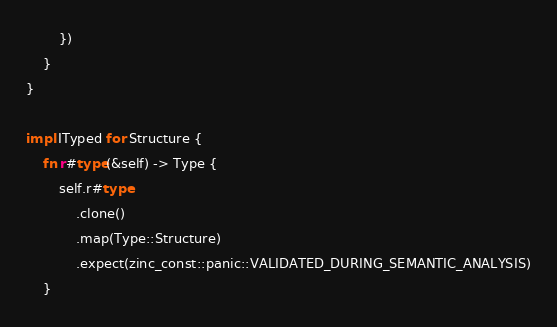<code> <loc_0><loc_0><loc_500><loc_500><_Rust_>        })
    }
}

impl ITyped for Structure {
    fn r#type(&self) -> Type {
        self.r#type
            .clone()
            .map(Type::Structure)
            .expect(zinc_const::panic::VALIDATED_DURING_SEMANTIC_ANALYSIS)
    }
</code> 